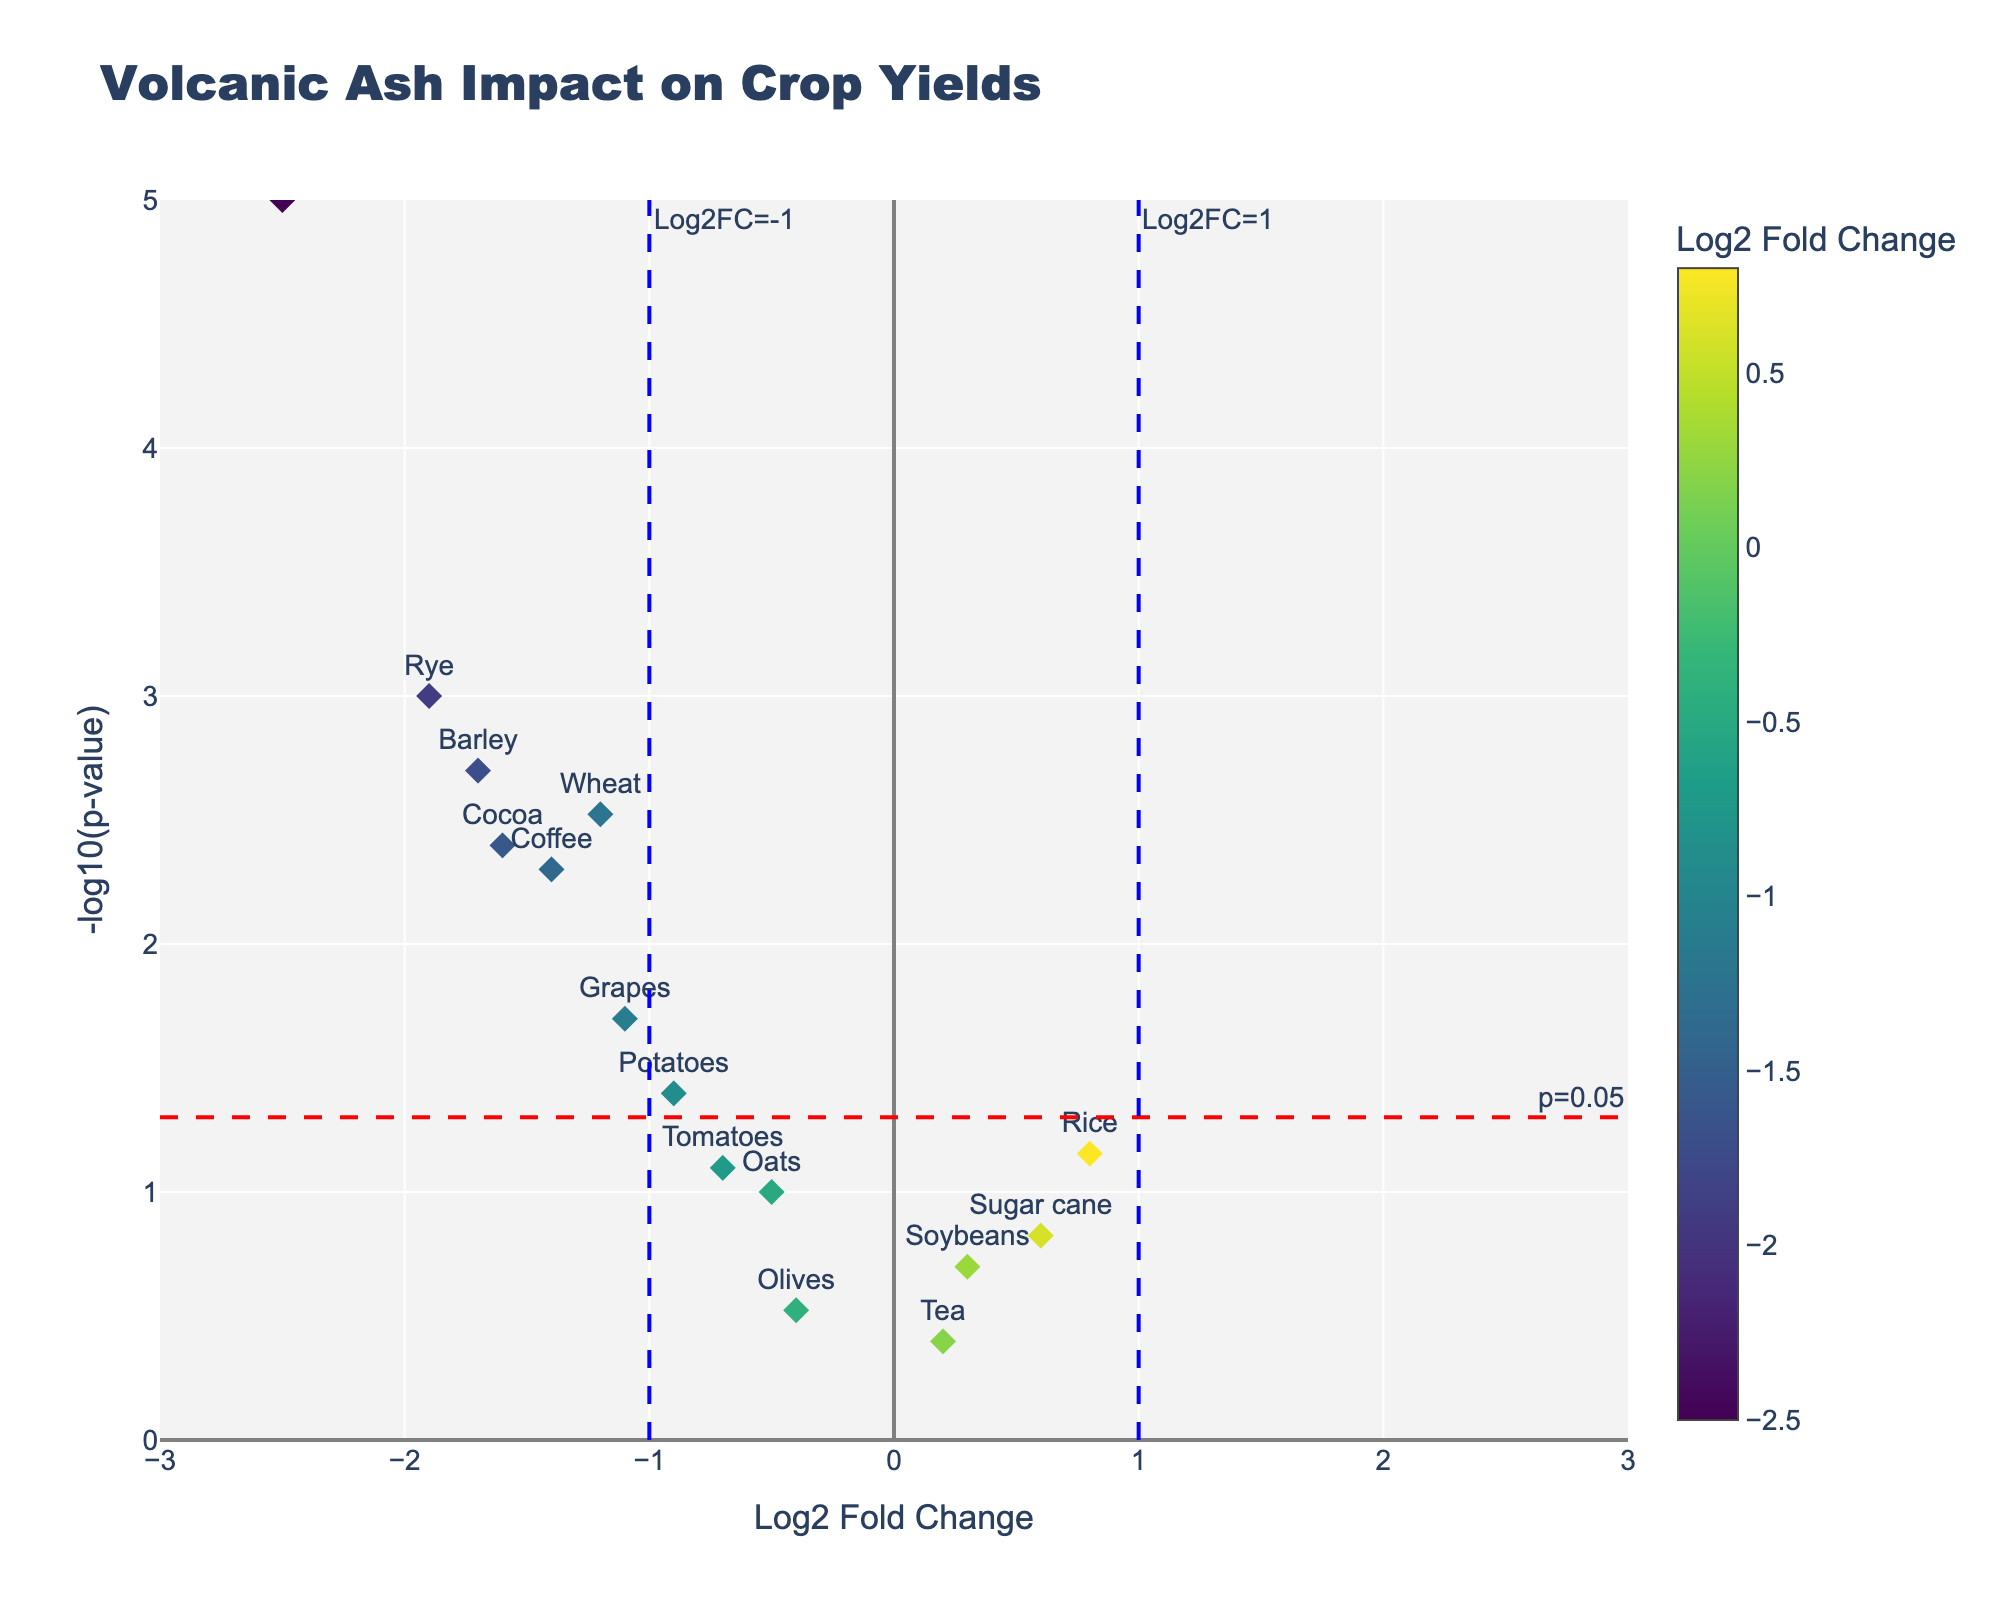What's the title of the plot? The title is displayed at the top of the figure in larger text, indicating the main topic of the visualization.
Answer: Volcanic Ash Impact on Crop Yields What do the x-axis and y-axis represent? The x-axis title shows "Log2 Fold Change," which measures the change in crop yields due to volcanic ash. The y-axis title "-log10(p-value)" represents the statistical significance of these changes.
Answer: Log2 Fold Change and -log10(p-value) How many crops are significantly affected by the volcanic ash? Significant effects are indicated by points above the horizontal red dashed line (p=0.05). You can count the number of points above this line.
Answer: 9 Which crop has the highest impact based on -log10(p-value)? The crop with the highest impact will be at the highest point on the y-axis. Look for the label closest to the top of the plot.
Answer: Maize How many crops show a negative Log2 Fold Change? Negative Log2 Fold Change values are on the left side of the y-axis (below zero). Count all the points on this side.
Answer: 10 Which region has the most representation in the plot? Look at the hover information or labels for the regions associated with each crop. Count the region that appears the most frequently.
Answer: Japan and Iceland (both appear twice) Which crops are above the Log2FC threshold of 1? The crops with Log2 Fold Change (x-value) greater than 1 will be to the right of the vertical blue dashed line (Log2FC=1). Identify the labels on this side.
Answer: None Are there any crops that are both significantly affected and not from Japan? Significant crops are above the red dashed line, and you need to exclude any from Japan. Count the remaining points.
Answer: 7 (Wheat, Maize, Barley, Potatoes, Coffee, Grapes, and Cocoa) What is the Log2 Fold Change range shown in the plot? The x-axis range defined by the analysis should be from the minimum to the maximum value seen on this axis. The given range in the plot is from -3 to 3.
Answer: -3 to 3 Which crop has the lowest p-value? The crop with the lowest p-value will be highest on the y-axis because -log10(p-value) increases as p-value decreases.
Answer: Maize 